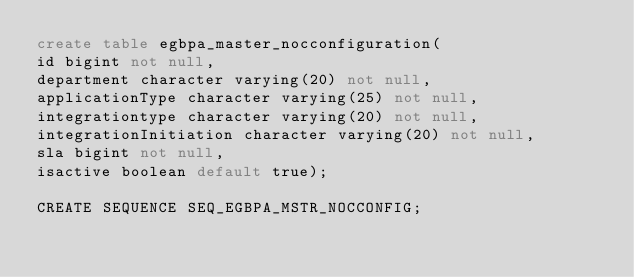Convert code to text. <code><loc_0><loc_0><loc_500><loc_500><_SQL_>create table egbpa_master_nocconfiguration(
id bigint not null,
department character varying(20) not null,
applicationType character varying(25) not null,
integrationtype character varying(20) not null,
integrationInitiation character varying(20) not null,
sla bigint not null,
isactive boolean default true);

CREATE SEQUENCE SEQ_EGBPA_MSTR_NOCCONFIG;</code> 